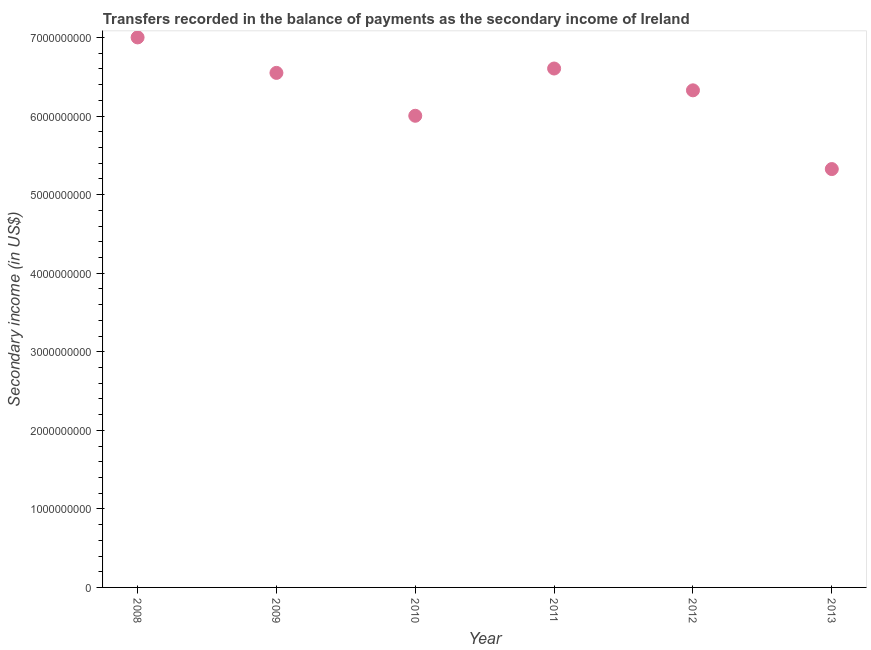What is the amount of secondary income in 2013?
Make the answer very short. 5.33e+09. Across all years, what is the maximum amount of secondary income?
Offer a terse response. 7.00e+09. Across all years, what is the minimum amount of secondary income?
Offer a terse response. 5.33e+09. What is the sum of the amount of secondary income?
Make the answer very short. 3.78e+1. What is the difference between the amount of secondary income in 2010 and 2012?
Give a very brief answer. -3.24e+08. What is the average amount of secondary income per year?
Your answer should be very brief. 6.30e+09. What is the median amount of secondary income?
Make the answer very short. 6.44e+09. In how many years, is the amount of secondary income greater than 3200000000 US$?
Provide a short and direct response. 6. What is the ratio of the amount of secondary income in 2008 to that in 2012?
Give a very brief answer. 1.11. Is the amount of secondary income in 2008 less than that in 2009?
Ensure brevity in your answer.  No. What is the difference between the highest and the second highest amount of secondary income?
Offer a terse response. 3.96e+08. Is the sum of the amount of secondary income in 2011 and 2013 greater than the maximum amount of secondary income across all years?
Your response must be concise. Yes. What is the difference between the highest and the lowest amount of secondary income?
Keep it short and to the point. 1.68e+09. How many years are there in the graph?
Your answer should be compact. 6. Are the values on the major ticks of Y-axis written in scientific E-notation?
Offer a very short reply. No. Does the graph contain any zero values?
Offer a very short reply. No. Does the graph contain grids?
Offer a very short reply. No. What is the title of the graph?
Your answer should be compact. Transfers recorded in the balance of payments as the secondary income of Ireland. What is the label or title of the Y-axis?
Ensure brevity in your answer.  Secondary income (in US$). What is the Secondary income (in US$) in 2008?
Provide a short and direct response. 7.00e+09. What is the Secondary income (in US$) in 2009?
Offer a very short reply. 6.55e+09. What is the Secondary income (in US$) in 2010?
Give a very brief answer. 6.00e+09. What is the Secondary income (in US$) in 2011?
Provide a short and direct response. 6.61e+09. What is the Secondary income (in US$) in 2012?
Provide a succinct answer. 6.33e+09. What is the Secondary income (in US$) in 2013?
Your response must be concise. 5.33e+09. What is the difference between the Secondary income (in US$) in 2008 and 2009?
Your response must be concise. 4.52e+08. What is the difference between the Secondary income (in US$) in 2008 and 2010?
Give a very brief answer. 9.97e+08. What is the difference between the Secondary income (in US$) in 2008 and 2011?
Offer a very short reply. 3.96e+08. What is the difference between the Secondary income (in US$) in 2008 and 2012?
Keep it short and to the point. 6.74e+08. What is the difference between the Secondary income (in US$) in 2008 and 2013?
Keep it short and to the point. 1.68e+09. What is the difference between the Secondary income (in US$) in 2009 and 2010?
Keep it short and to the point. 5.46e+08. What is the difference between the Secondary income (in US$) in 2009 and 2011?
Your answer should be very brief. -5.56e+07. What is the difference between the Secondary income (in US$) in 2009 and 2012?
Give a very brief answer. 2.22e+08. What is the difference between the Secondary income (in US$) in 2009 and 2013?
Your response must be concise. 1.22e+09. What is the difference between the Secondary income (in US$) in 2010 and 2011?
Offer a terse response. -6.02e+08. What is the difference between the Secondary income (in US$) in 2010 and 2012?
Provide a succinct answer. -3.24e+08. What is the difference between the Secondary income (in US$) in 2010 and 2013?
Your response must be concise. 6.78e+08. What is the difference between the Secondary income (in US$) in 2011 and 2012?
Provide a succinct answer. 2.78e+08. What is the difference between the Secondary income (in US$) in 2011 and 2013?
Provide a succinct answer. 1.28e+09. What is the difference between the Secondary income (in US$) in 2012 and 2013?
Offer a terse response. 1.00e+09. What is the ratio of the Secondary income (in US$) in 2008 to that in 2009?
Your response must be concise. 1.07. What is the ratio of the Secondary income (in US$) in 2008 to that in 2010?
Provide a succinct answer. 1.17. What is the ratio of the Secondary income (in US$) in 2008 to that in 2011?
Make the answer very short. 1.06. What is the ratio of the Secondary income (in US$) in 2008 to that in 2012?
Keep it short and to the point. 1.11. What is the ratio of the Secondary income (in US$) in 2008 to that in 2013?
Make the answer very short. 1.31. What is the ratio of the Secondary income (in US$) in 2009 to that in 2010?
Your answer should be compact. 1.09. What is the ratio of the Secondary income (in US$) in 2009 to that in 2012?
Provide a succinct answer. 1.03. What is the ratio of the Secondary income (in US$) in 2009 to that in 2013?
Your answer should be very brief. 1.23. What is the ratio of the Secondary income (in US$) in 2010 to that in 2011?
Your answer should be very brief. 0.91. What is the ratio of the Secondary income (in US$) in 2010 to that in 2012?
Provide a succinct answer. 0.95. What is the ratio of the Secondary income (in US$) in 2010 to that in 2013?
Make the answer very short. 1.13. What is the ratio of the Secondary income (in US$) in 2011 to that in 2012?
Give a very brief answer. 1.04. What is the ratio of the Secondary income (in US$) in 2011 to that in 2013?
Provide a short and direct response. 1.24. What is the ratio of the Secondary income (in US$) in 2012 to that in 2013?
Keep it short and to the point. 1.19. 